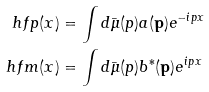<formula> <loc_0><loc_0><loc_500><loc_500>\ h f p ( x ) & = \int d \bar { \mu } ( p ) a ( \mathbf p ) e ^ { - i p x } \\ \ h f m ( x ) & = \int d \bar { \mu } ( p ) b ^ { * } ( \mathbf p ) e ^ { i p x }</formula> 